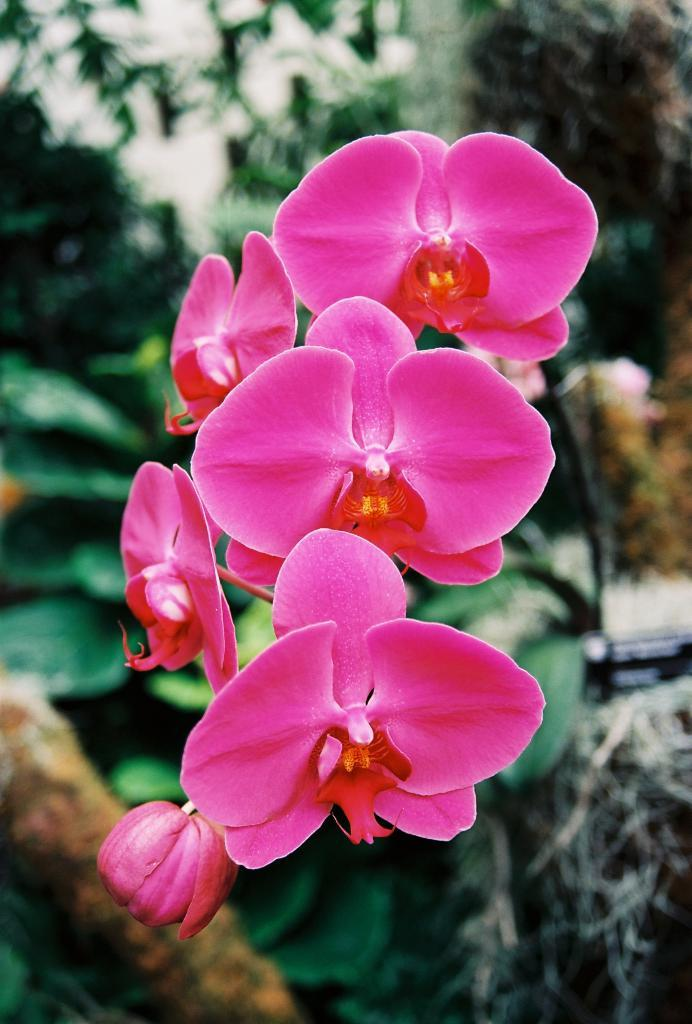What is present in the picture? There are flowers in the picture. Can you describe the background of the image? The background of the image is blurred. How many laborers are working on the branch in the image? There are no laborers or branches present in the image; it features flowers and a blurred background. 